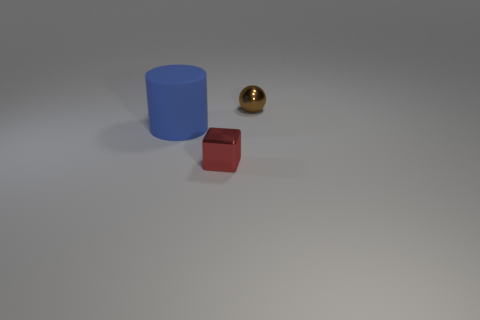Add 1 tiny brown objects. How many objects exist? 4 Subtract all spheres. How many objects are left? 2 Subtract 1 brown balls. How many objects are left? 2 Subtract 1 cylinders. How many cylinders are left? 0 Subtract all green balls. Subtract all purple cylinders. How many balls are left? 1 Subtract all large yellow objects. Subtract all shiny objects. How many objects are left? 1 Add 1 shiny cubes. How many shiny cubes are left? 2 Add 3 green metal blocks. How many green metal blocks exist? 3 